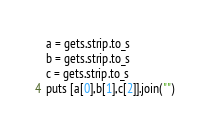Convert code to text. <code><loc_0><loc_0><loc_500><loc_500><_Ruby_>a = gets.strip.to_s
b = gets.strip.to_s
c = gets.strip.to_s
puts [a[0],b[1],c[2]].join("")</code> 